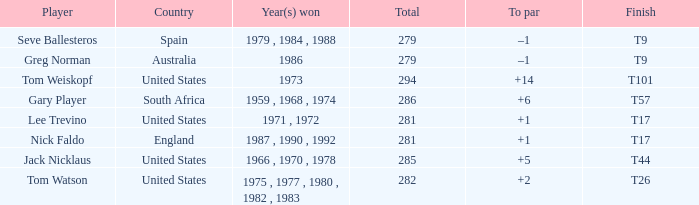What is Australia's to par? –1. 